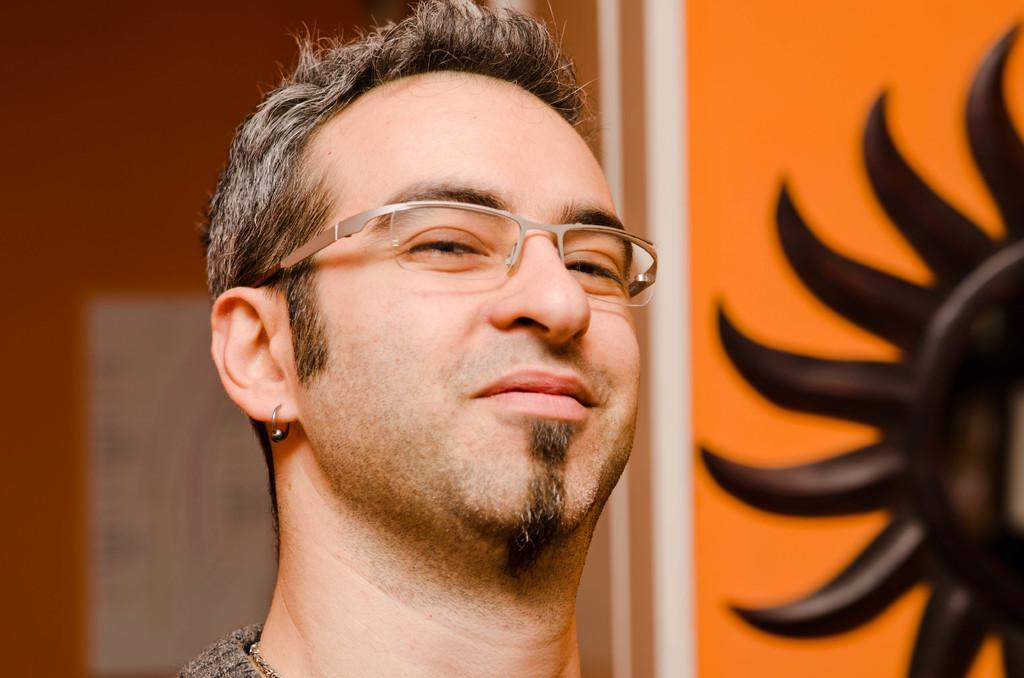Who is the main subject in the image? There is a man in the center of the image. What can be seen on the man's face? The man is wearing spectacles. What is visible in the background of the image? There is a wall in the background of the image. What symbol can be seen on the right side of the image? There is a sun symbol on the right side of the image. How does the man get into trouble with the fog in the image? There is no fog present in the image, so the man cannot get into trouble with it. 